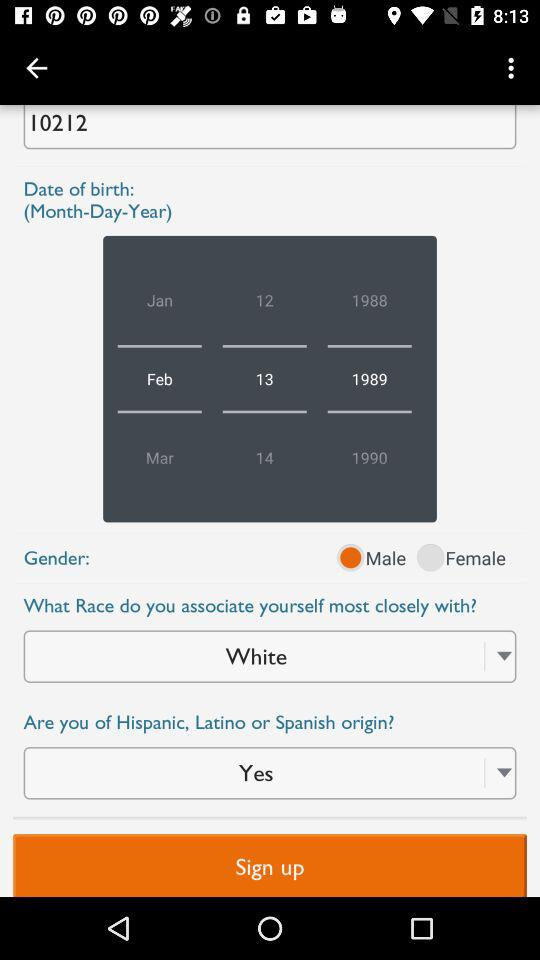What is the selected gender? The selected gender is male. 